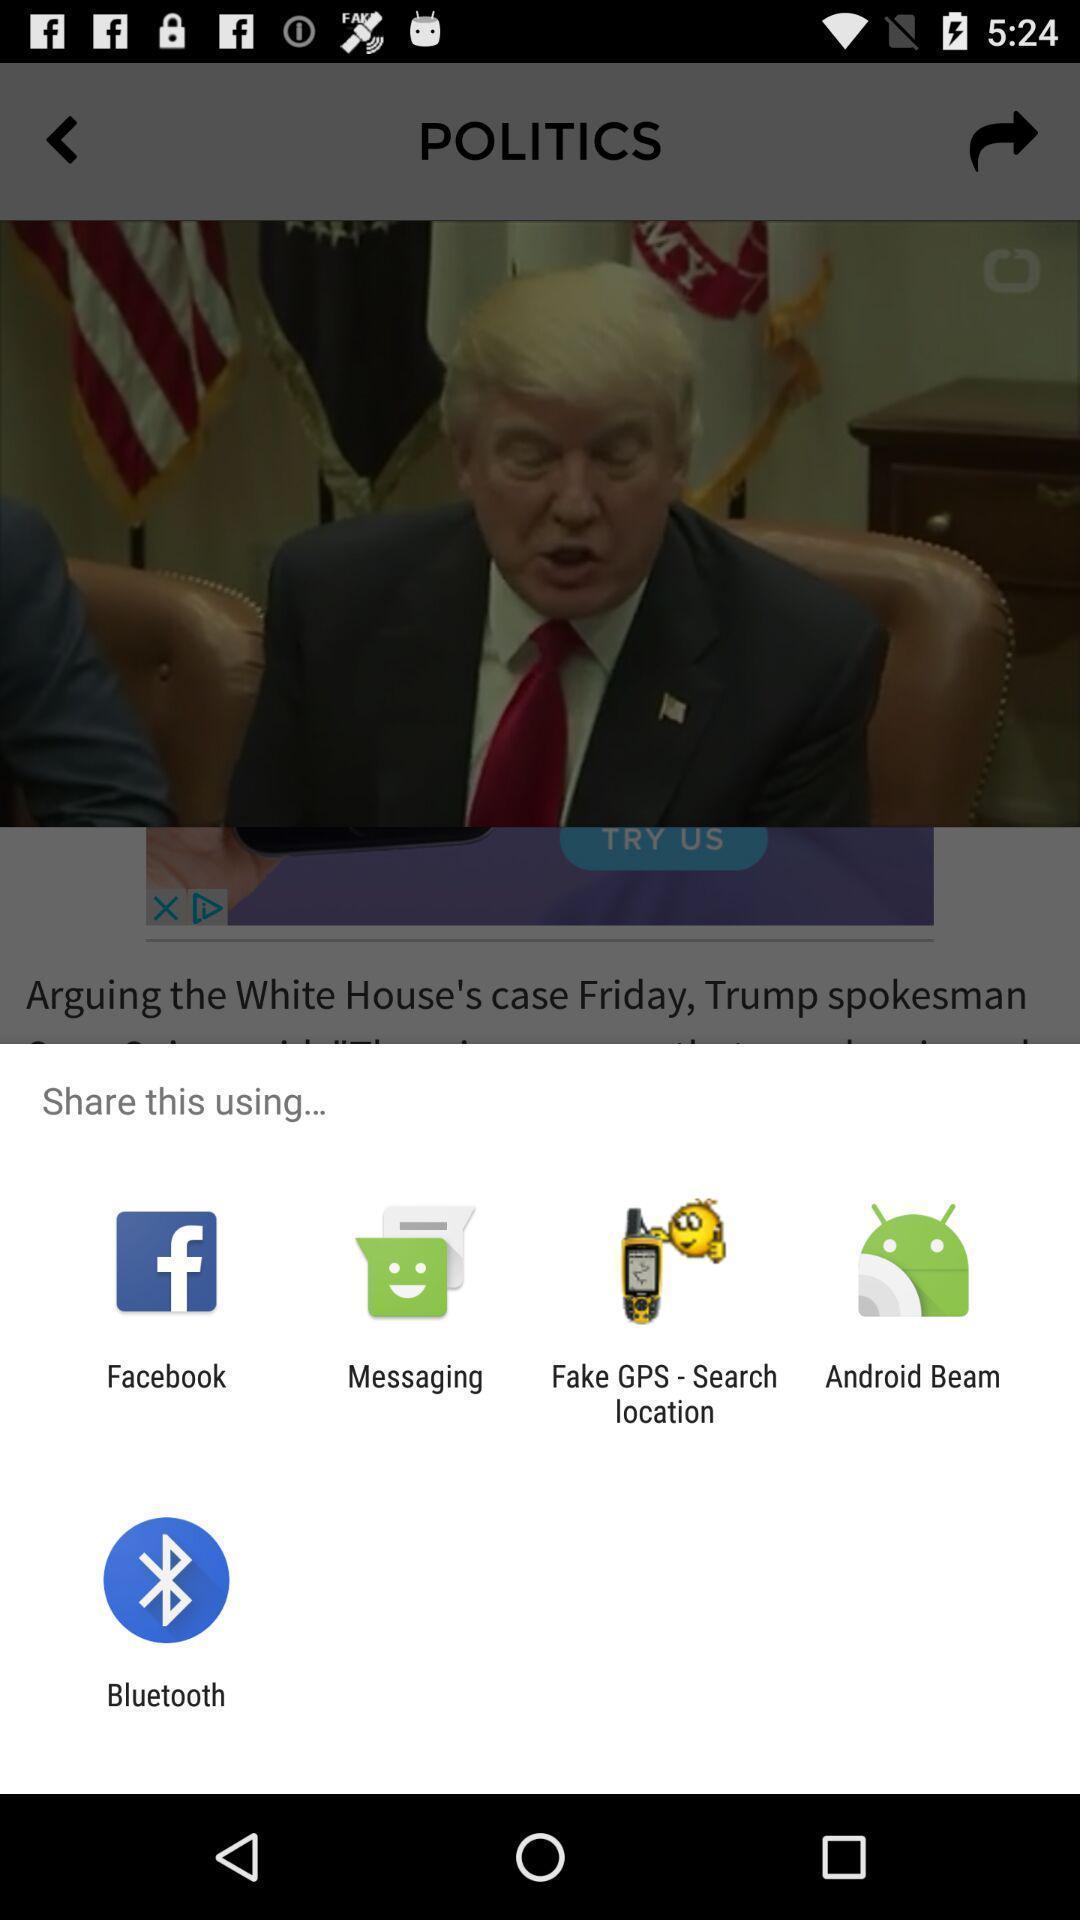Summarize the main components in this picture. Pop-up for showing different share options. 